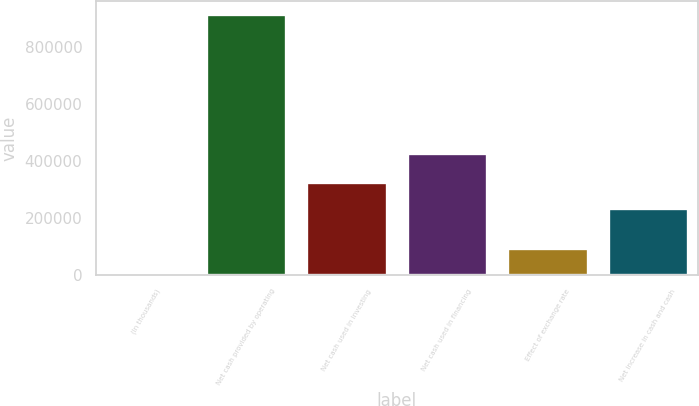Convert chart. <chart><loc_0><loc_0><loc_500><loc_500><bar_chart><fcel>(In thousands)<fcel>Net cash provided by operating<fcel>Net cash used in investing<fcel>Net cash used in financing<fcel>Effect of exchange rate<fcel>Net increase in cash and cash<nl><fcel>2013<fcel>913188<fcel>325214<fcel>428510<fcel>93130.5<fcel>234096<nl></chart> 